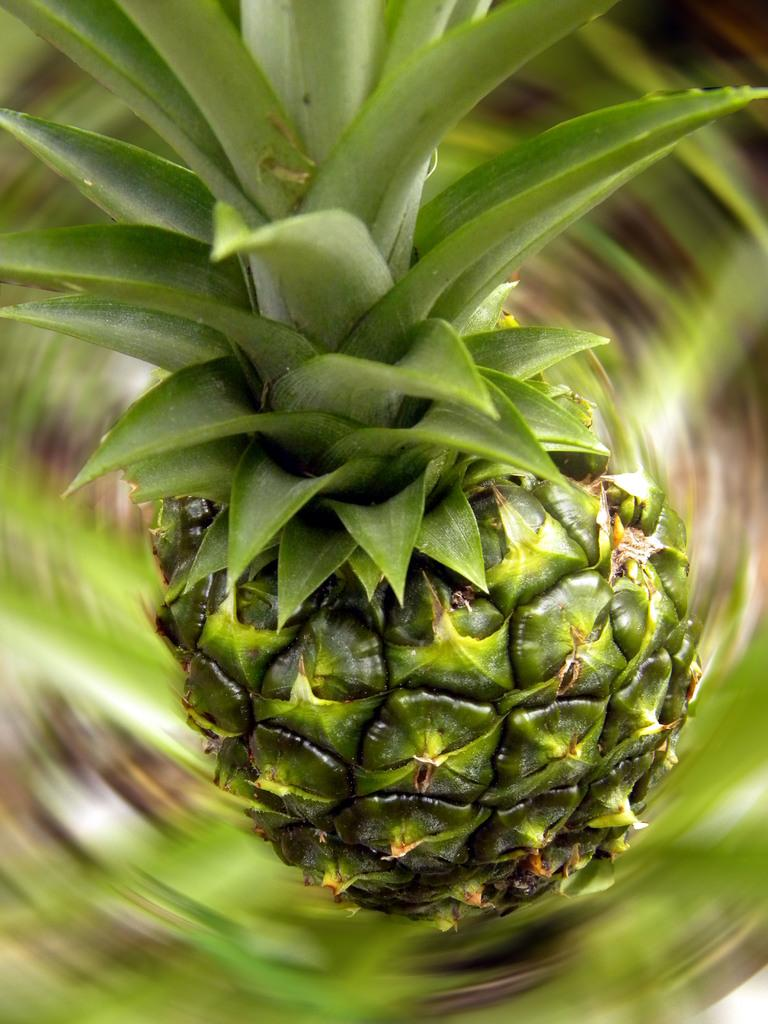What type of fruit is in the image? There is a pineapple in the image. What colors can be seen on the pineapple? The pineapple has green and brown colors. What color is the background of the image? The background of the image is green. What type of roof can be seen on the edge of the image? There is no roof present in the image; it features a pineapple with a green background. 